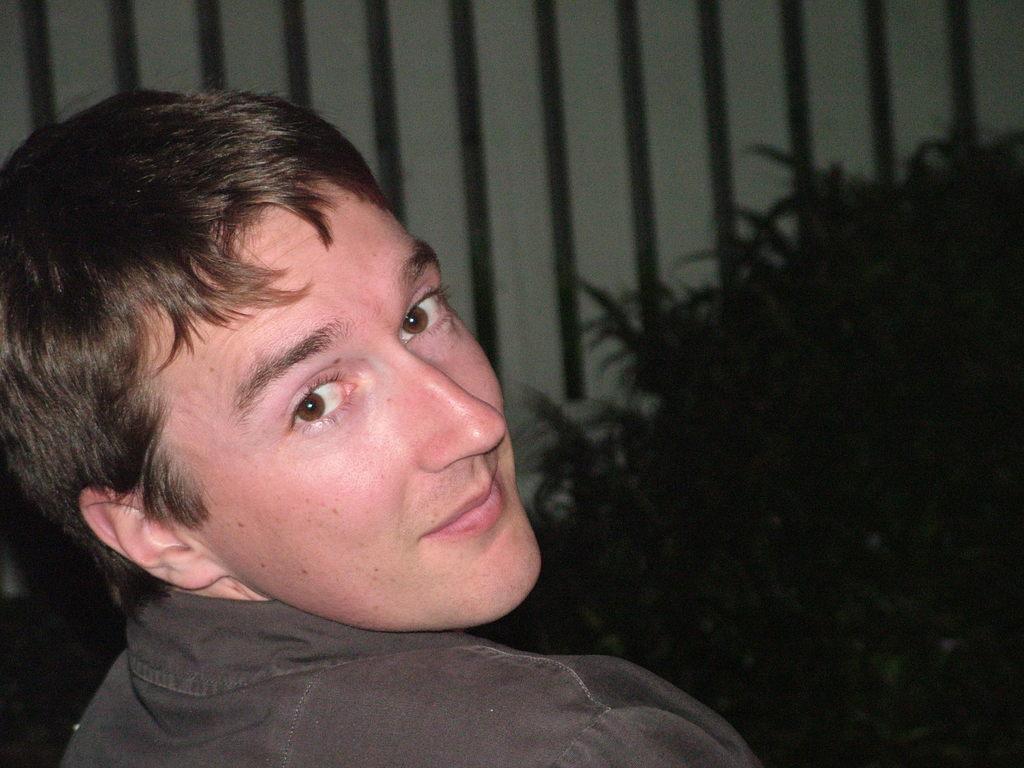Please provide a concise description of this image. We can see a man and he is smiling. This is plant. 